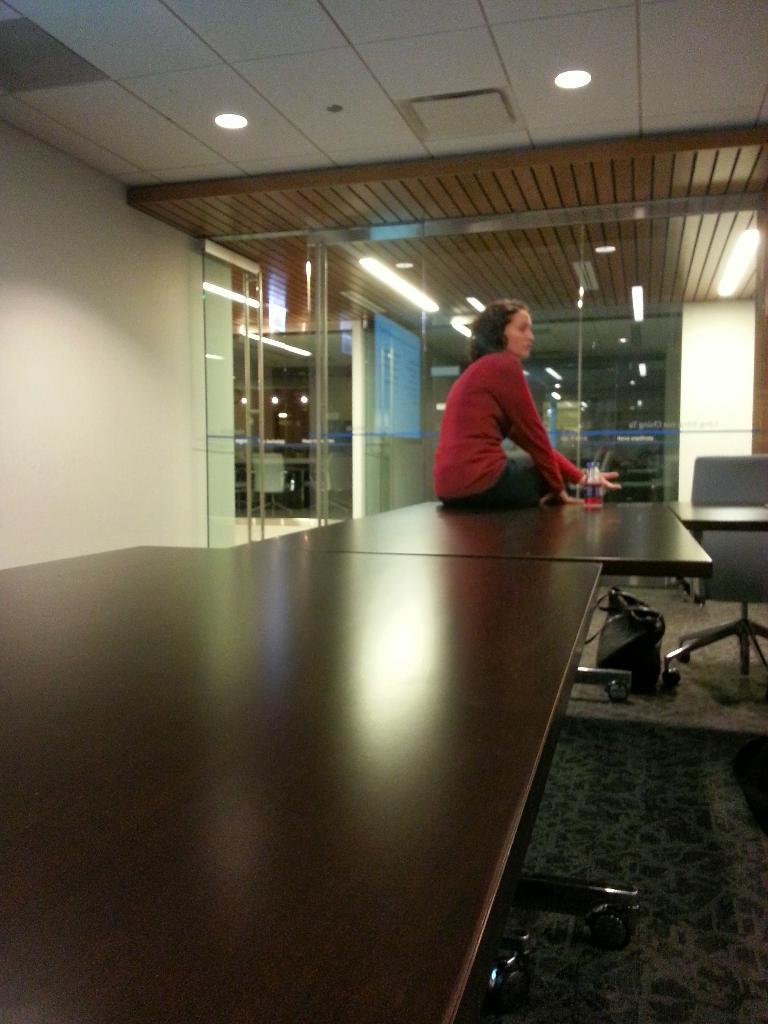What is the woman doing in the image? The woman is sitting on a table in the image. What object can be seen near the woman? There is a bag in the image. What type of furniture is present in the image? There are chairs in the image. What can be seen in the background of the image? There are lights and a screen visible in the background. What type of game is being played on the screen in the image? There is no game being played on the screen in the image; it is just visible in the background. Can you see a drain in the image? There is no drain present in the image. 